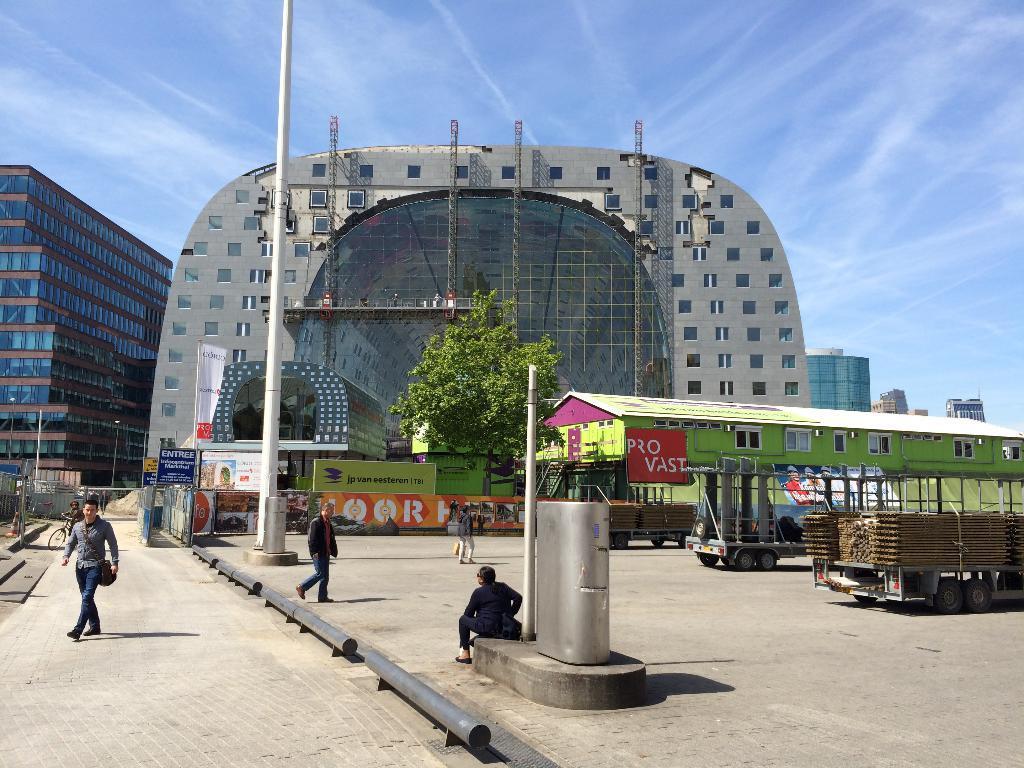Can you describe this image briefly? In this image there are a few people walking and there is a person sat on the concrete platform, beside them there are two trucks parked, in the background of the image there are trees, utility poles and buildings. 